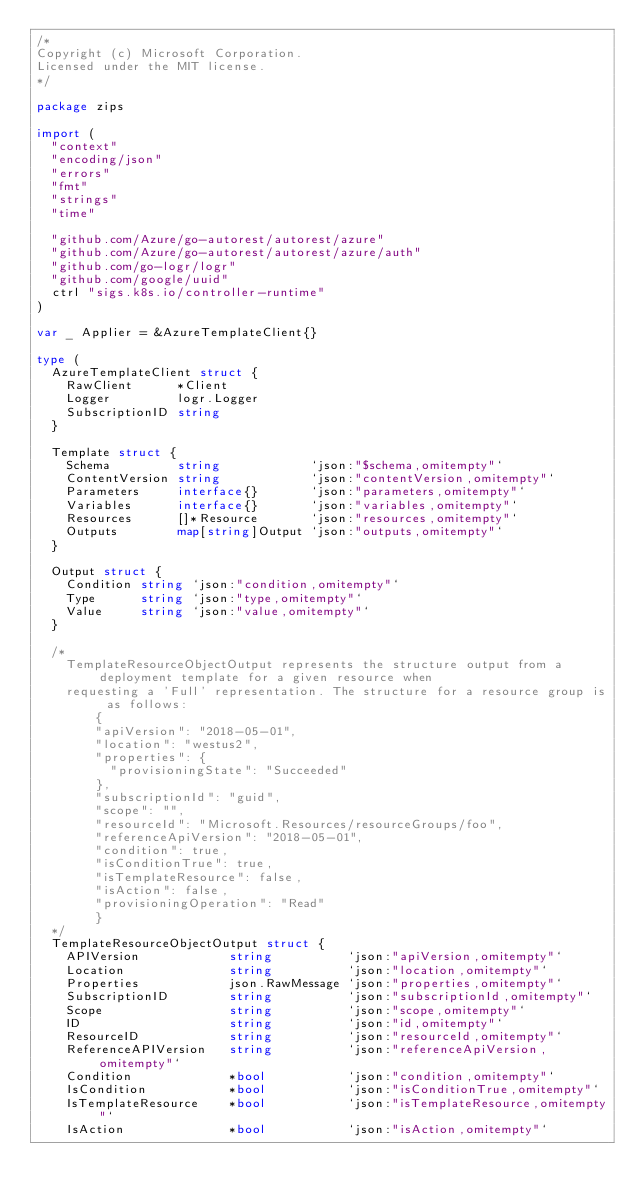Convert code to text. <code><loc_0><loc_0><loc_500><loc_500><_Go_>/*
Copyright (c) Microsoft Corporation.
Licensed under the MIT license.
*/

package zips

import (
	"context"
	"encoding/json"
	"errors"
	"fmt"
	"strings"
	"time"

	"github.com/Azure/go-autorest/autorest/azure"
	"github.com/Azure/go-autorest/autorest/azure/auth"
	"github.com/go-logr/logr"
	"github.com/google/uuid"
	ctrl "sigs.k8s.io/controller-runtime"
)

var _ Applier = &AzureTemplateClient{}

type (
	AzureTemplateClient struct {
		RawClient      *Client
		Logger         logr.Logger
		SubscriptionID string
	}

	Template struct {
		Schema         string            `json:"$schema,omitempty"`
		ContentVersion string            `json:"contentVersion,omitempty"`
		Parameters     interface{}       `json:"parameters,omitempty"`
		Variables      interface{}       `json:"variables,omitempty"`
		Resources      []*Resource       `json:"resources,omitempty"`
		Outputs        map[string]Output `json:"outputs,omitempty"`
	}

	Output struct {
		Condition string `json:"condition,omitempty"`
		Type      string `json:"type,omitempty"`
		Value     string `json:"value,omitempty"`
	}

	/*
		TemplateResourceObjectOutput represents the structure output from a deployment template for a given resource when
		requesting a 'Full' representation. The structure for a resource group is as follows:
		    {
			  "apiVersion": "2018-05-01",
			  "location": "westus2",
			  "properties": {
			    "provisioningState": "Succeeded"
			  },
			  "subscriptionId": "guid",
			  "scope": "",
			  "resourceId": "Microsoft.Resources/resourceGroups/foo",
			  "referenceApiVersion": "2018-05-01",
			  "condition": true,
			  "isConditionTrue": true,
			  "isTemplateResource": false,
			  "isAction": false,
			  "provisioningOperation": "Read"
		    }
	*/
	TemplateResourceObjectOutput struct {
		APIVersion            string          `json:"apiVersion,omitempty"`
		Location              string          `json:"location,omitempty"`
		Properties            json.RawMessage `json:"properties,omitempty"`
		SubscriptionID        string          `json:"subscriptionId,omitempty"`
		Scope                 string          `json:"scope,omitempty"`
		ID                    string          `json:"id,omitempty"`
		ResourceID            string          `json:"resourceId,omitempty"`
		ReferenceAPIVersion   string          `json:"referenceApiVersion,omitempty"`
		Condition             *bool           `json:"condition,omitempty"`
		IsCondition           *bool           `json:"isConditionTrue,omitempty"`
		IsTemplateResource    *bool           `json:"isTemplateResource,omitempty"`
		IsAction              *bool           `json:"isAction,omitempty"`</code> 